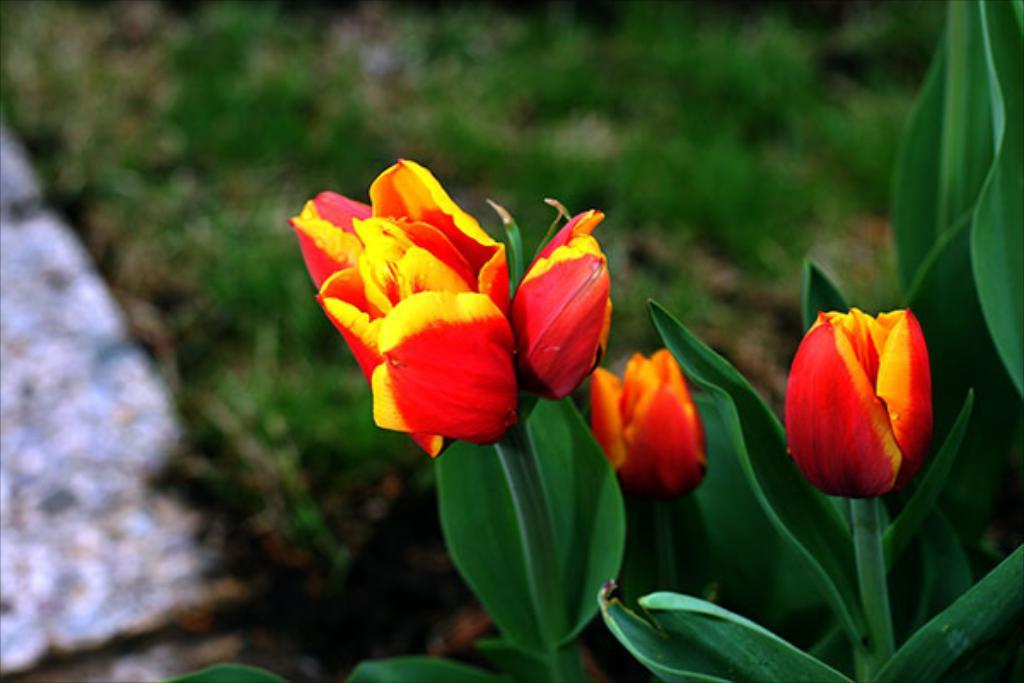What type of flowers are in the foreground of the image? There are three red color flowers in the foreground of the image. What are the flowers connected to? The flowers are associated with plants. What can be seen in the background of the image? There is grass visible in the background of the image. What is the interest rate on the flowers in the image? There is no mention of interest rates in the image, as it features flowers and plants. 